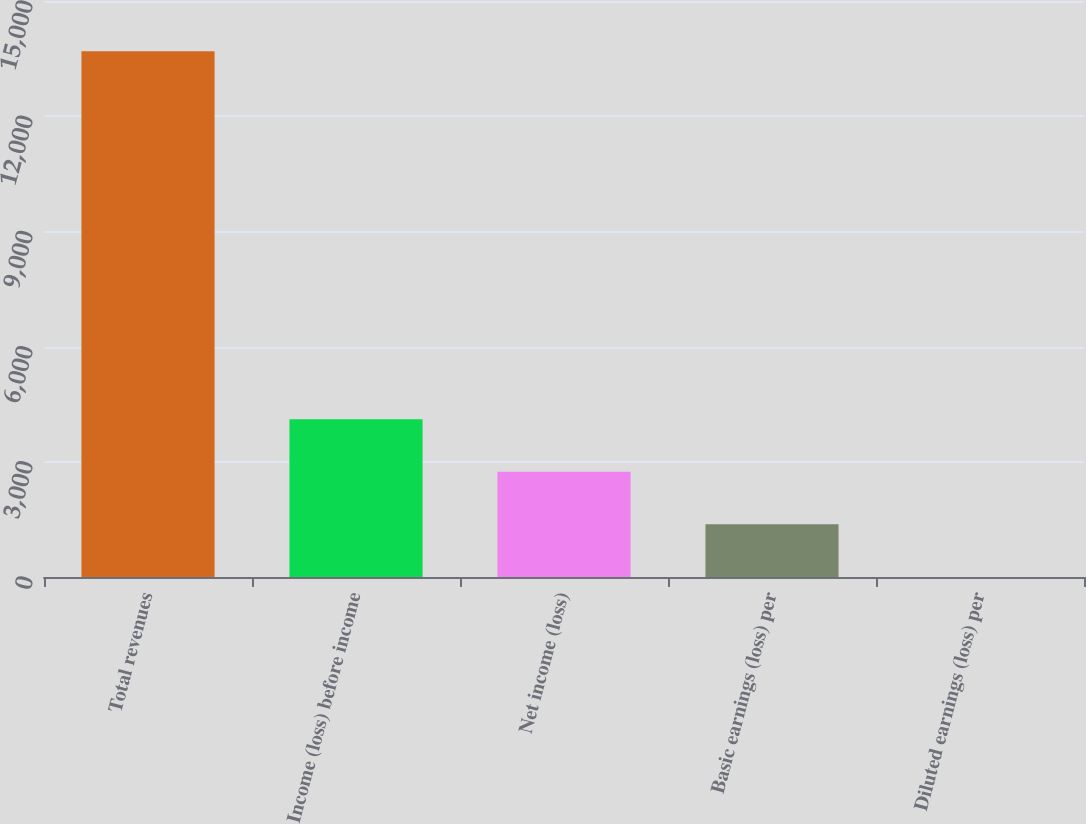<chart> <loc_0><loc_0><loc_500><loc_500><bar_chart><fcel>Total revenues<fcel>Income (loss) before income<fcel>Net income (loss)<fcel>Basic earnings (loss) per<fcel>Diluted earnings (loss) per<nl><fcel>13694<fcel>4110.28<fcel>2741.18<fcel>1372.08<fcel>2.98<nl></chart> 